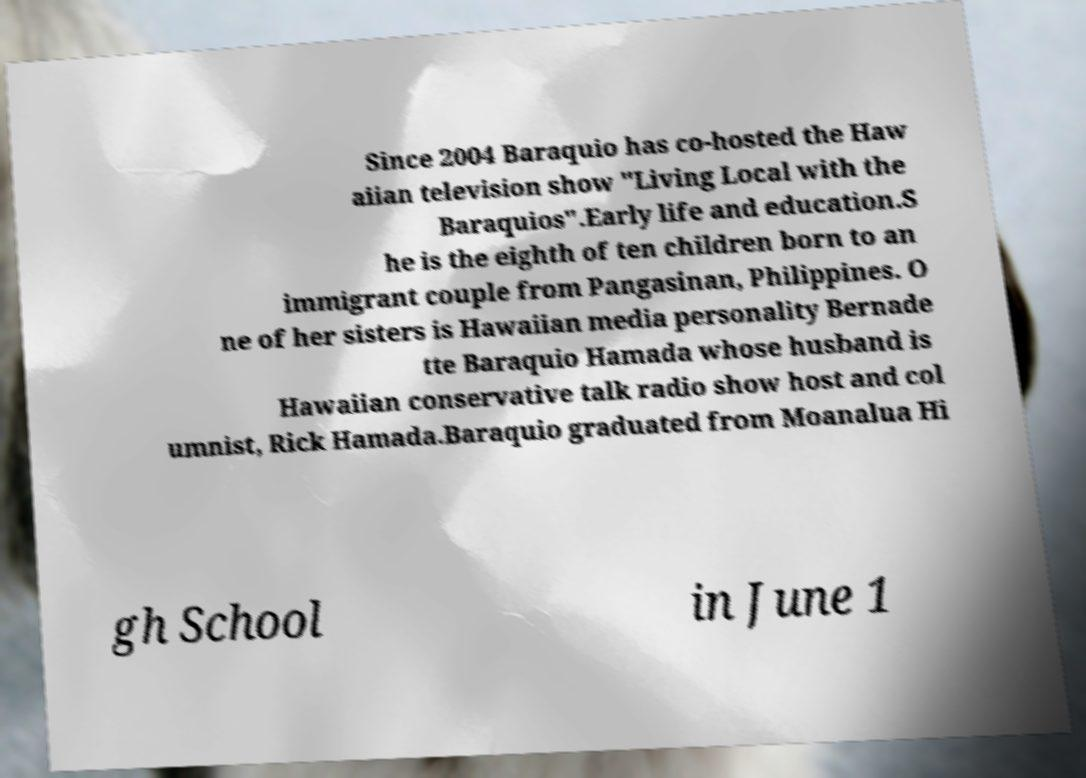I need the written content from this picture converted into text. Can you do that? Since 2004 Baraquio has co-hosted the Haw aiian television show "Living Local with the Baraquios".Early life and education.S he is the eighth of ten children born to an immigrant couple from Pangasinan, Philippines. O ne of her sisters is Hawaiian media personality Bernade tte Baraquio Hamada whose husband is Hawaiian conservative talk radio show host and col umnist, Rick Hamada.Baraquio graduated from Moanalua Hi gh School in June 1 